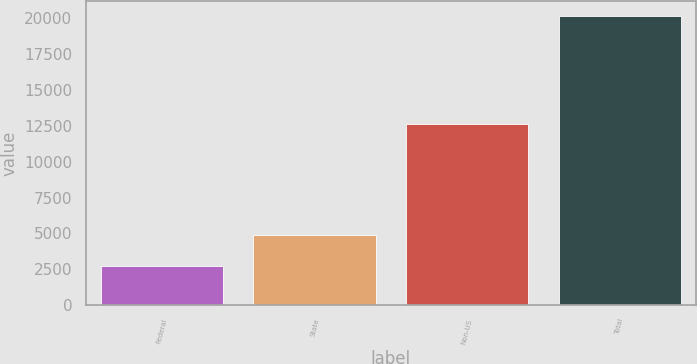Convert chart. <chart><loc_0><loc_0><loc_500><loc_500><bar_chart><fcel>Federal<fcel>State<fcel>Non-US<fcel>Total<nl><fcel>2688<fcel>4917<fcel>12603<fcel>20208<nl></chart> 